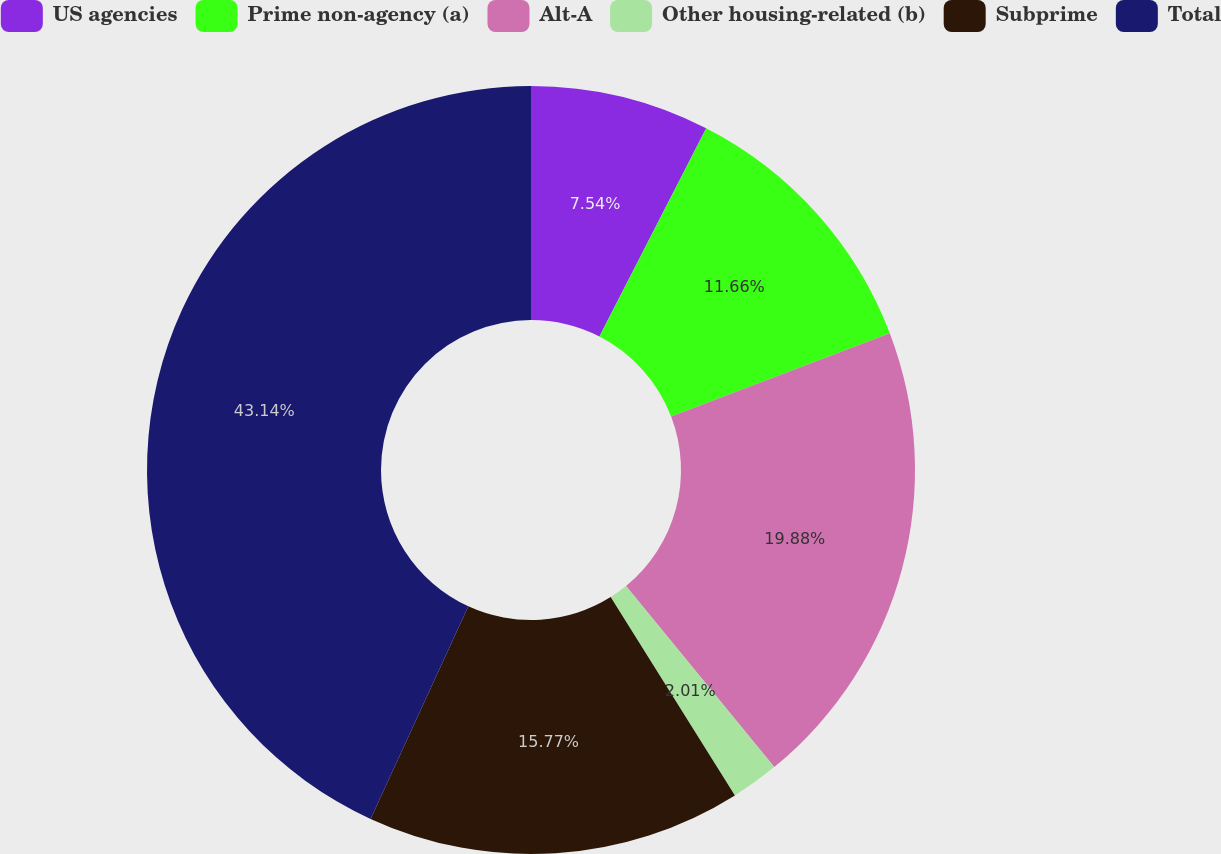Convert chart. <chart><loc_0><loc_0><loc_500><loc_500><pie_chart><fcel>US agencies<fcel>Prime non-agency (a)<fcel>Alt-A<fcel>Other housing-related (b)<fcel>Subprime<fcel>Total<nl><fcel>7.54%<fcel>11.66%<fcel>19.88%<fcel>2.01%<fcel>15.77%<fcel>43.14%<nl></chart> 